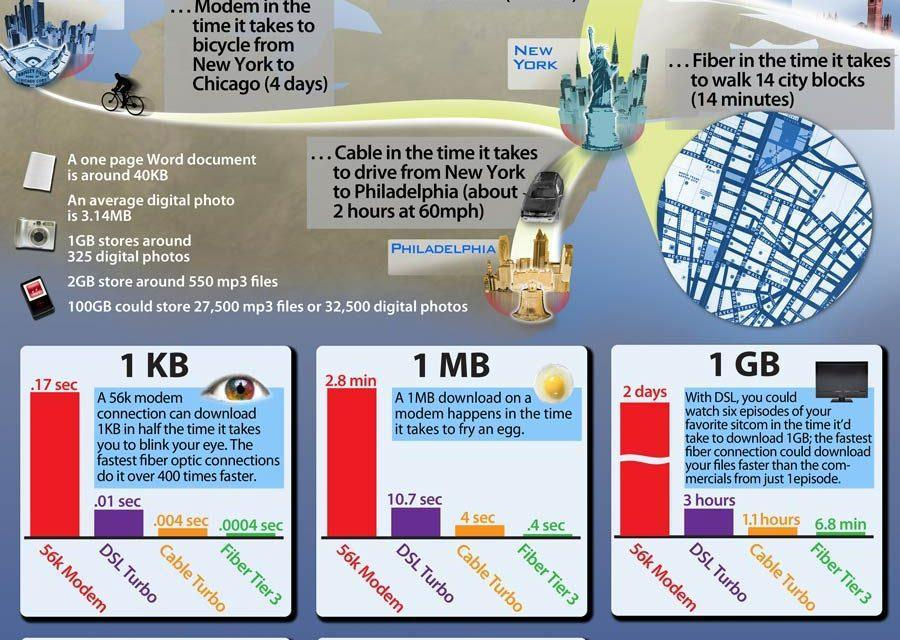What amount of data can downloaded by Fiber Tier 3 in 0.4 s?
Answer the question with a short phrase. 1 MB Which are two cities mentioned in the document? New York, Philadelphia What amount of data can downloaded with DSL Turbo in 0.01 sec? 1 KB Which are the three methods of transmitting data ? Modem, Cable, Fiber Which modem takes the highest time to download the user's favorite sitcom? 56k Modem What amount of data can downloaded with Cable Turbo in 1.1 hr? 1 GB What is the download speed for 1KB using Cable Turbo, 0.004, 0.0004, or .4? 0.004 sec Which mode of transmitting information takes the least amount of time, Modem, Cable, or Fiber? Fiber 